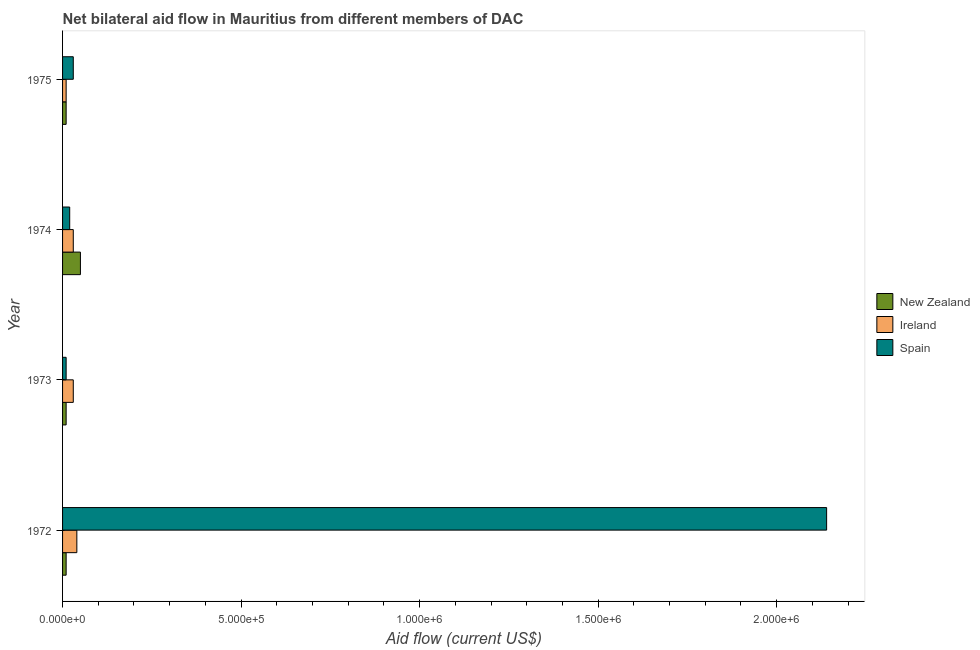How many groups of bars are there?
Ensure brevity in your answer.  4. Are the number of bars on each tick of the Y-axis equal?
Make the answer very short. Yes. How many bars are there on the 3rd tick from the top?
Your answer should be compact. 3. How many bars are there on the 1st tick from the bottom?
Your answer should be compact. 3. What is the label of the 2nd group of bars from the top?
Offer a terse response. 1974. In how many cases, is the number of bars for a given year not equal to the number of legend labels?
Your response must be concise. 0. What is the amount of aid provided by spain in 1975?
Your response must be concise. 3.00e+04. Across all years, what is the maximum amount of aid provided by spain?
Provide a succinct answer. 2.14e+06. Across all years, what is the minimum amount of aid provided by new zealand?
Your answer should be compact. 10000. In which year was the amount of aid provided by new zealand minimum?
Provide a succinct answer. 1972. What is the total amount of aid provided by spain in the graph?
Offer a very short reply. 2.20e+06. What is the difference between the amount of aid provided by new zealand in 1972 and that in 1974?
Your response must be concise. -4.00e+04. What is the average amount of aid provided by spain per year?
Ensure brevity in your answer.  5.50e+05. What is the ratio of the amount of aid provided by spain in 1972 to that in 1974?
Your answer should be compact. 107. What is the difference between the highest and the lowest amount of aid provided by spain?
Provide a short and direct response. 2.13e+06. In how many years, is the amount of aid provided by ireland greater than the average amount of aid provided by ireland taken over all years?
Offer a very short reply. 3. Is the sum of the amount of aid provided by spain in 1972 and 1974 greater than the maximum amount of aid provided by ireland across all years?
Your response must be concise. Yes. What does the 2nd bar from the top in 1973 represents?
Give a very brief answer. Ireland. Is it the case that in every year, the sum of the amount of aid provided by new zealand and amount of aid provided by ireland is greater than the amount of aid provided by spain?
Provide a succinct answer. No. How many bars are there?
Your answer should be very brief. 12. How many years are there in the graph?
Your answer should be very brief. 4. What is the difference between two consecutive major ticks on the X-axis?
Offer a very short reply. 5.00e+05. Does the graph contain grids?
Provide a short and direct response. No. Where does the legend appear in the graph?
Ensure brevity in your answer.  Center right. What is the title of the graph?
Your answer should be very brief. Net bilateral aid flow in Mauritius from different members of DAC. What is the label or title of the X-axis?
Give a very brief answer. Aid flow (current US$). What is the Aid flow (current US$) in New Zealand in 1972?
Offer a terse response. 10000. What is the Aid flow (current US$) of Ireland in 1972?
Provide a short and direct response. 4.00e+04. What is the Aid flow (current US$) in Spain in 1972?
Offer a terse response. 2.14e+06. What is the Aid flow (current US$) in Ireland in 1973?
Offer a very short reply. 3.00e+04. What is the Aid flow (current US$) of New Zealand in 1974?
Offer a terse response. 5.00e+04. What is the Aid flow (current US$) of Spain in 1974?
Your answer should be very brief. 2.00e+04. What is the Aid flow (current US$) of Ireland in 1975?
Ensure brevity in your answer.  10000. Across all years, what is the maximum Aid flow (current US$) in Spain?
Give a very brief answer. 2.14e+06. What is the total Aid flow (current US$) of Spain in the graph?
Ensure brevity in your answer.  2.20e+06. What is the difference between the Aid flow (current US$) of Spain in 1972 and that in 1973?
Provide a succinct answer. 2.13e+06. What is the difference between the Aid flow (current US$) of Ireland in 1972 and that in 1974?
Your answer should be very brief. 10000. What is the difference between the Aid flow (current US$) in Spain in 1972 and that in 1974?
Offer a terse response. 2.12e+06. What is the difference between the Aid flow (current US$) in Spain in 1972 and that in 1975?
Offer a very short reply. 2.11e+06. What is the difference between the Aid flow (current US$) in New Zealand in 1973 and that in 1974?
Offer a terse response. -4.00e+04. What is the difference between the Aid flow (current US$) in Spain in 1973 and that in 1974?
Make the answer very short. -10000. What is the difference between the Aid flow (current US$) in Ireland in 1973 and that in 1975?
Ensure brevity in your answer.  2.00e+04. What is the difference between the Aid flow (current US$) of New Zealand in 1972 and the Aid flow (current US$) of Spain in 1973?
Your answer should be compact. 0. What is the difference between the Aid flow (current US$) of New Zealand in 1972 and the Aid flow (current US$) of Ireland in 1975?
Offer a terse response. 0. What is the difference between the Aid flow (current US$) of New Zealand in 1973 and the Aid flow (current US$) of Ireland in 1974?
Keep it short and to the point. -2.00e+04. What is the difference between the Aid flow (current US$) of New Zealand in 1973 and the Aid flow (current US$) of Ireland in 1975?
Ensure brevity in your answer.  0. What is the difference between the Aid flow (current US$) in New Zealand in 1973 and the Aid flow (current US$) in Spain in 1975?
Your response must be concise. -2.00e+04. What is the difference between the Aid flow (current US$) of New Zealand in 1974 and the Aid flow (current US$) of Spain in 1975?
Make the answer very short. 2.00e+04. What is the difference between the Aid flow (current US$) in Ireland in 1974 and the Aid flow (current US$) in Spain in 1975?
Your answer should be compact. 0. What is the average Aid flow (current US$) of New Zealand per year?
Keep it short and to the point. 2.00e+04. What is the average Aid flow (current US$) of Ireland per year?
Your answer should be compact. 2.75e+04. What is the average Aid flow (current US$) of Spain per year?
Make the answer very short. 5.50e+05. In the year 1972, what is the difference between the Aid flow (current US$) of New Zealand and Aid flow (current US$) of Spain?
Give a very brief answer. -2.13e+06. In the year 1972, what is the difference between the Aid flow (current US$) in Ireland and Aid flow (current US$) in Spain?
Make the answer very short. -2.10e+06. In the year 1974, what is the difference between the Aid flow (current US$) of New Zealand and Aid flow (current US$) of Ireland?
Provide a short and direct response. 2.00e+04. In the year 1974, what is the difference between the Aid flow (current US$) of New Zealand and Aid flow (current US$) of Spain?
Offer a very short reply. 3.00e+04. In the year 1974, what is the difference between the Aid flow (current US$) of Ireland and Aid flow (current US$) of Spain?
Keep it short and to the point. 10000. In the year 1975, what is the difference between the Aid flow (current US$) of New Zealand and Aid flow (current US$) of Spain?
Your answer should be very brief. -2.00e+04. In the year 1975, what is the difference between the Aid flow (current US$) in Ireland and Aid flow (current US$) in Spain?
Provide a short and direct response. -2.00e+04. What is the ratio of the Aid flow (current US$) in Spain in 1972 to that in 1973?
Offer a very short reply. 214. What is the ratio of the Aid flow (current US$) of New Zealand in 1972 to that in 1974?
Your answer should be very brief. 0.2. What is the ratio of the Aid flow (current US$) in Ireland in 1972 to that in 1974?
Offer a very short reply. 1.33. What is the ratio of the Aid flow (current US$) of Spain in 1972 to that in 1974?
Your response must be concise. 107. What is the ratio of the Aid flow (current US$) in New Zealand in 1972 to that in 1975?
Provide a short and direct response. 1. What is the ratio of the Aid flow (current US$) in Ireland in 1972 to that in 1975?
Make the answer very short. 4. What is the ratio of the Aid flow (current US$) in Spain in 1972 to that in 1975?
Ensure brevity in your answer.  71.33. What is the ratio of the Aid flow (current US$) of New Zealand in 1973 to that in 1975?
Provide a succinct answer. 1. What is the ratio of the Aid flow (current US$) of Spain in 1973 to that in 1975?
Give a very brief answer. 0.33. What is the ratio of the Aid flow (current US$) of New Zealand in 1974 to that in 1975?
Make the answer very short. 5. What is the difference between the highest and the second highest Aid flow (current US$) of Spain?
Ensure brevity in your answer.  2.11e+06. What is the difference between the highest and the lowest Aid flow (current US$) of New Zealand?
Offer a terse response. 4.00e+04. What is the difference between the highest and the lowest Aid flow (current US$) in Ireland?
Make the answer very short. 3.00e+04. What is the difference between the highest and the lowest Aid flow (current US$) in Spain?
Make the answer very short. 2.13e+06. 